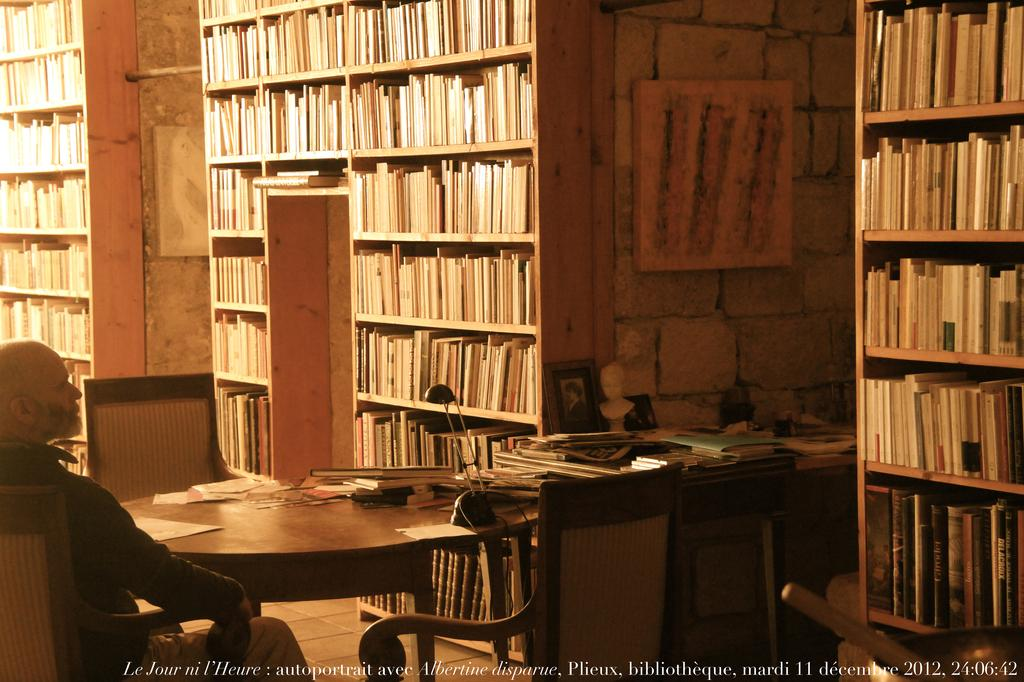<image>
Offer a succinct explanation of the picture presented. Library with a man inside and the year 2012 on the bottom. 